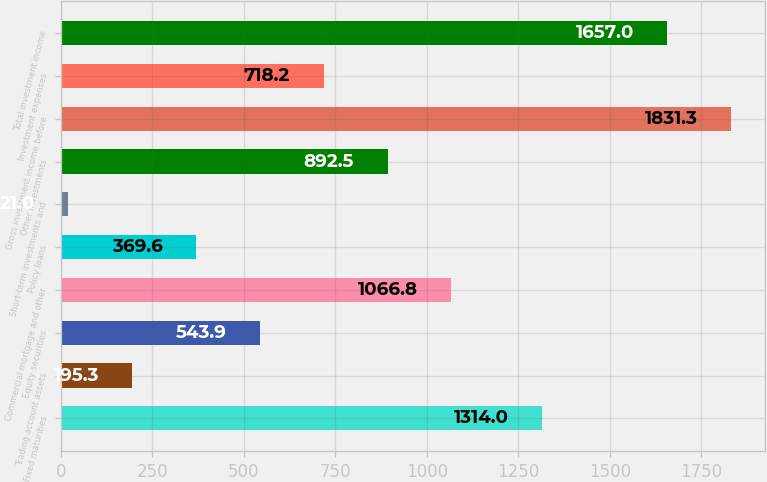Convert chart to OTSL. <chart><loc_0><loc_0><loc_500><loc_500><bar_chart><fcel>Fixed maturities<fcel>Trading account assets<fcel>Equity securities<fcel>Commercial mortgage and other<fcel>Policy loans<fcel>Short-term investments and<fcel>Other investments<fcel>Gross investment income before<fcel>Investment expenses<fcel>Total investment income<nl><fcel>1314<fcel>195.3<fcel>543.9<fcel>1066.8<fcel>369.6<fcel>21<fcel>892.5<fcel>1831.3<fcel>718.2<fcel>1657<nl></chart> 